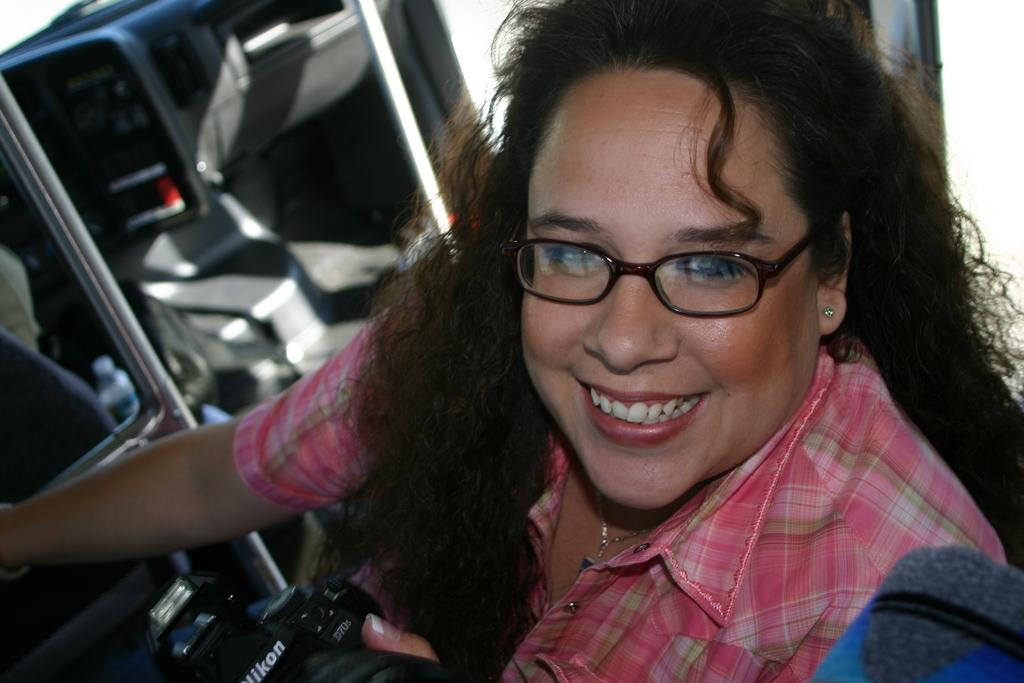Who is the main subject in the picture? There is a woman in the picture. What is the woman doing in the image? The woman is smiling. What accessory is the woman wearing in the image? The woman is wearing spectacles. What object is the woman holding in her hand? The woman is holding a camera in her hand. What type of flesh can be seen on the woman's face in the image? There is no flesh visible on the woman's face in the image; it is a photograph, not a painting or drawing. 